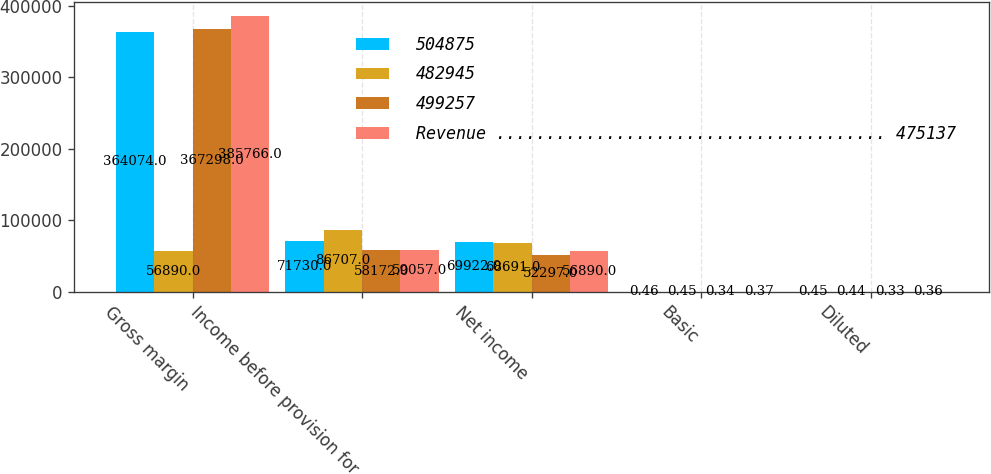Convert chart to OTSL. <chart><loc_0><loc_0><loc_500><loc_500><stacked_bar_chart><ecel><fcel>Gross margin<fcel>Income before provision for<fcel>Net income<fcel>Basic<fcel>Diluted<nl><fcel>504875<fcel>364074<fcel>71730<fcel>69922<fcel>0.46<fcel>0.45<nl><fcel>482945<fcel>56890<fcel>86707<fcel>68691<fcel>0.45<fcel>0.44<nl><fcel>499257<fcel>367298<fcel>58172<fcel>52297<fcel>0.34<fcel>0.33<nl><fcel>Revenue ....................................... 475137<fcel>385766<fcel>59057<fcel>56890<fcel>0.37<fcel>0.36<nl></chart> 